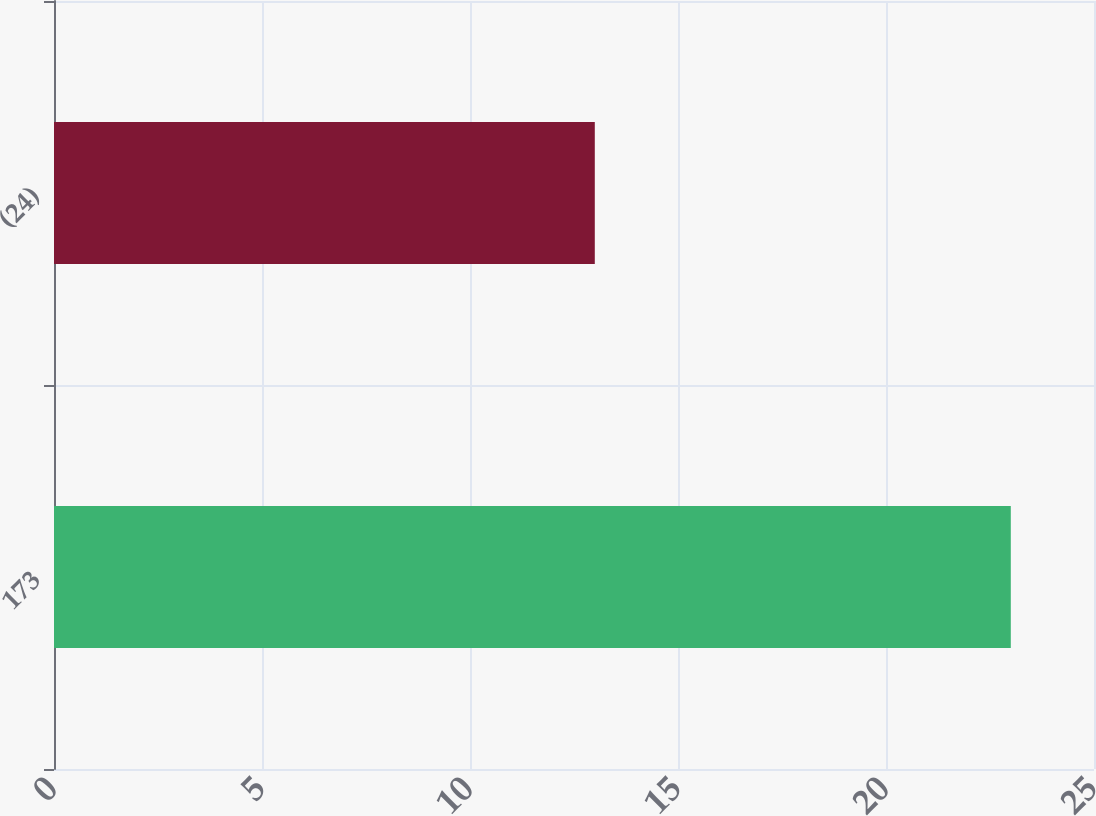<chart> <loc_0><loc_0><loc_500><loc_500><bar_chart><fcel>173<fcel>(24)<nl><fcel>23<fcel>13<nl></chart> 